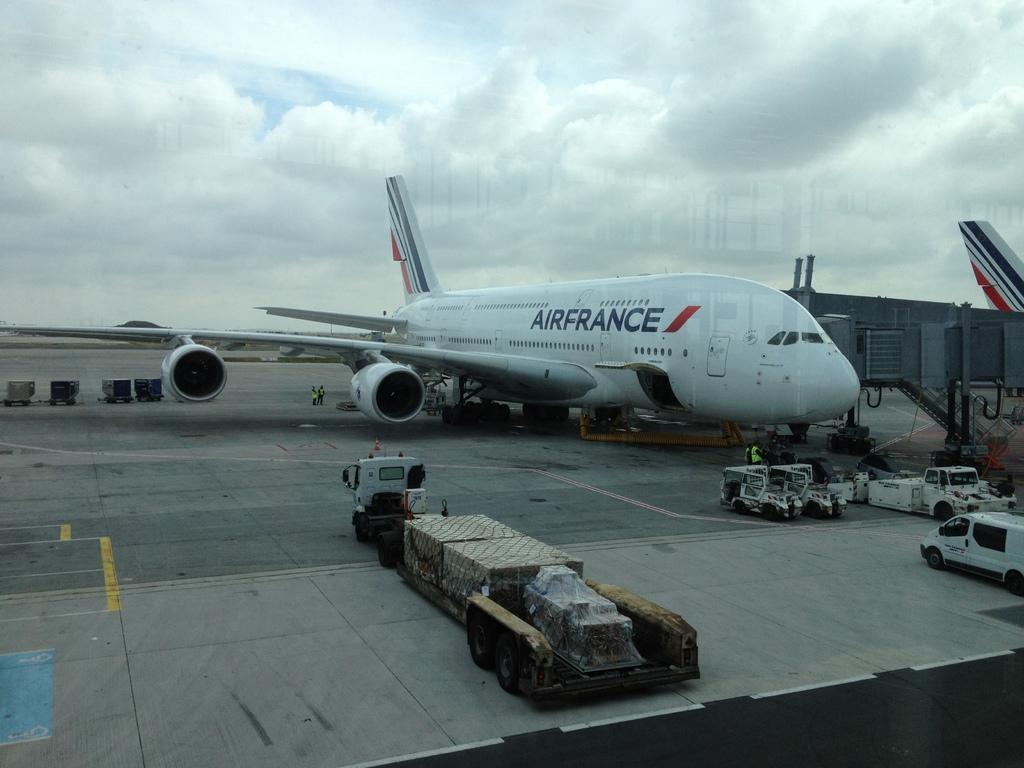How would you summarize this image in a sentence or two? In this image there are airplanes, vehicles, and some boxes and luggage and there are some people. At the bottom there is a walkway, and on the right side of the image there is a staircase, airplane, and objects. At the top there is sky. 